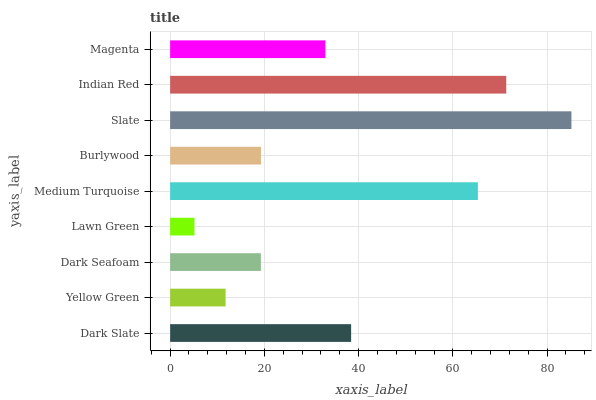Is Lawn Green the minimum?
Answer yes or no. Yes. Is Slate the maximum?
Answer yes or no. Yes. Is Yellow Green the minimum?
Answer yes or no. No. Is Yellow Green the maximum?
Answer yes or no. No. Is Dark Slate greater than Yellow Green?
Answer yes or no. Yes. Is Yellow Green less than Dark Slate?
Answer yes or no. Yes. Is Yellow Green greater than Dark Slate?
Answer yes or no. No. Is Dark Slate less than Yellow Green?
Answer yes or no. No. Is Magenta the high median?
Answer yes or no. Yes. Is Magenta the low median?
Answer yes or no. Yes. Is Lawn Green the high median?
Answer yes or no. No. Is Dark Seafoam the low median?
Answer yes or no. No. 